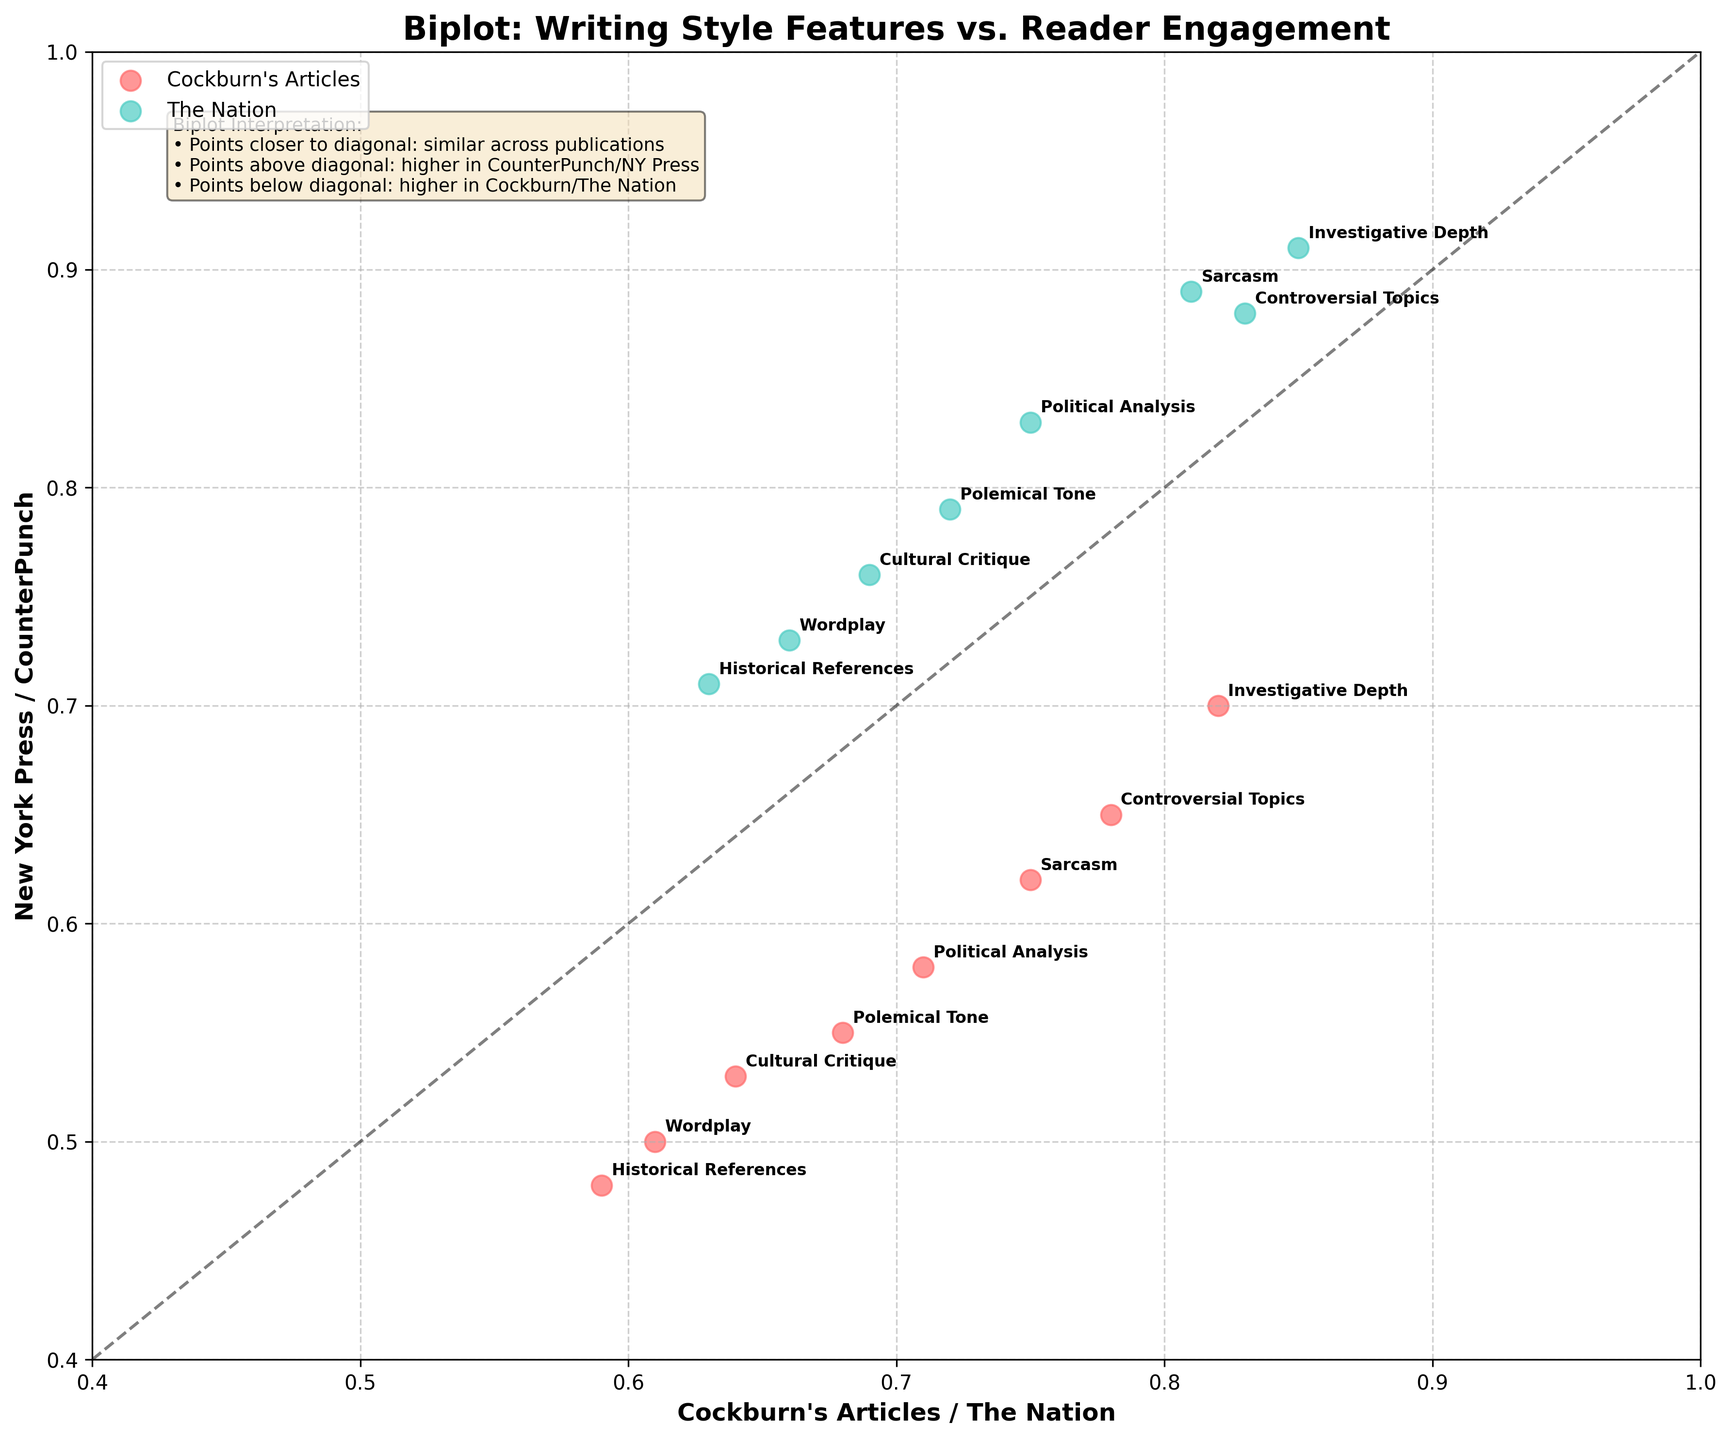How many engagement metrics are represented in the biplot? The engagement metrics are labeled alongside the points, indicating eight different metrics used in the analysis.
Answer: Eight What is the title of the biplot? The title is located at the top of the figure, it provides an overall description of what the plot represents. The title is "Biplot: Writing Style Features vs. Reader Engagement".
Answer: Biplot: Writing Style Features vs. Reader Engagement Which writing style feature shows a higher engagement metric for Cockburn's Articles compared to New York Press? By looking at the plot, finding the points below the diagonal line will show the writing style features that have a higher engagement metric for Cockburn's Articles compared to New York Press. One of these points is "Investigative Depth".
Answer: Investigative Depth Which publication is represented by the points colored in red? The legend located in the plot tells us what color represents which publication. The red points are labeled "Cockburn's Articles".
Answer: Cockburn's Articles Which writing style feature has the same engagement values in both The Nation and CounterPunch? Points on the diagonal line indicate equal engagement values for both publications. Looking at these points, "Wordplay" has values that place it on the diagonal.
Answer: Wordplay Which writing style feature is most strongly correlated with reader comments across all publications? To determine which feature has the highest engagement metric with comments in all publications, compare the positions of all points labeled with "Comments". "Investigative Depth" is the feature that appears highest on the y-axis for comments in all publications.
Answer: Investigative Depth Is there a writing style feature that generally shows higher engagement values in New York Press compared to Cockburn's Articles? Points that are above the diagonal line will indicate higher values in New York Press compared to Cockburn's Articles. "Cultural Critique" is an example of such a point.
Answer: Cultural Critique Which feature is closest to the bottom left of the plot and how might this be interpreted regarding engagement? The feature closest to the bottom left point (low values on both axes) represents a style with generally lower engagement in both Cockburn’s articles and NY Press. "Wordplay" appears near this region, indicating lower engagement.
Answer: Wordplay How does engagement in sarcastic writing compare across the publications? To compare engagement for sarcasm, look at the positions of the points labeled "Sarcasm" in the plot. It appears higher in CounterPunch compared to Cockburn's Articles and New York Press.
Answer: Higher in CounterPunch 